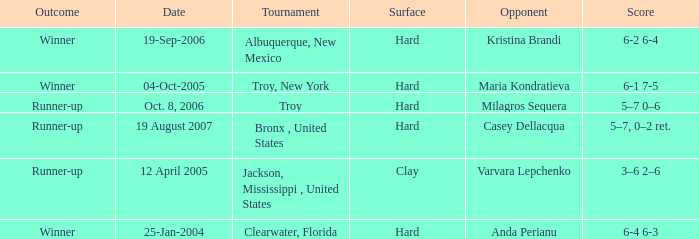What is the final score of the tournament played in Clearwater, Florida? 6-4 6-3. 